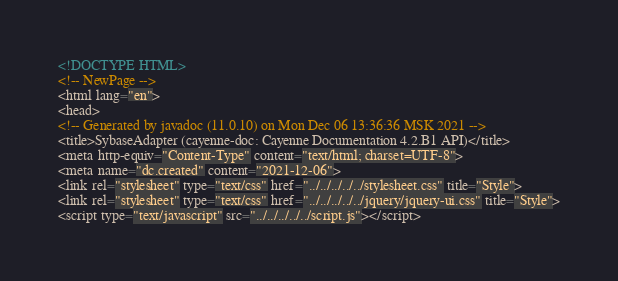Convert code to text. <code><loc_0><loc_0><loc_500><loc_500><_HTML_><!DOCTYPE HTML>
<!-- NewPage -->
<html lang="en">
<head>
<!-- Generated by javadoc (11.0.10) on Mon Dec 06 13:36:36 MSK 2021 -->
<title>SybaseAdapter (cayenne-doc: Cayenne Documentation 4.2.B1 API)</title>
<meta http-equiv="Content-Type" content="text/html; charset=UTF-8">
<meta name="dc.created" content="2021-12-06">
<link rel="stylesheet" type="text/css" href="../../../../../stylesheet.css" title="Style">
<link rel="stylesheet" type="text/css" href="../../../../../jquery/jquery-ui.css" title="Style">
<script type="text/javascript" src="../../../../../script.js"></script></code> 